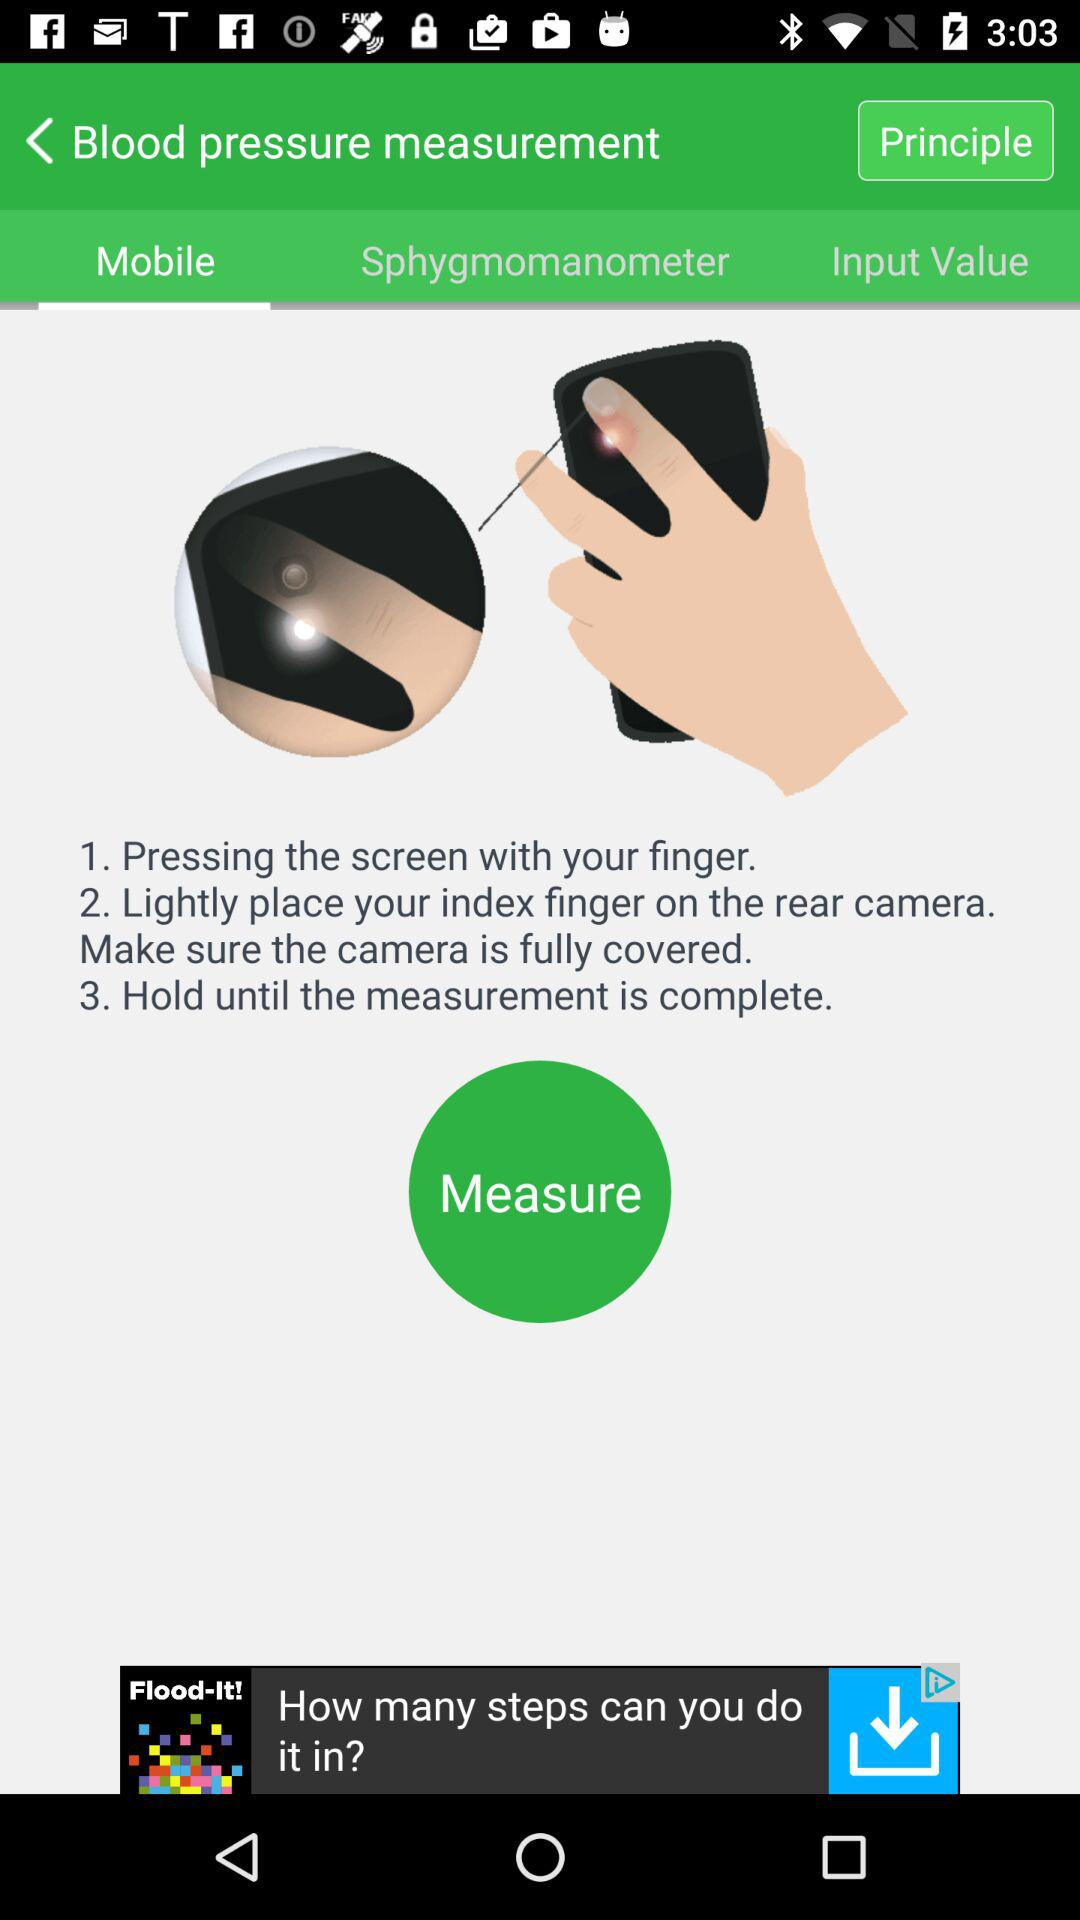How many steps are there in the measurement process?
Answer the question using a single word or phrase. 3 